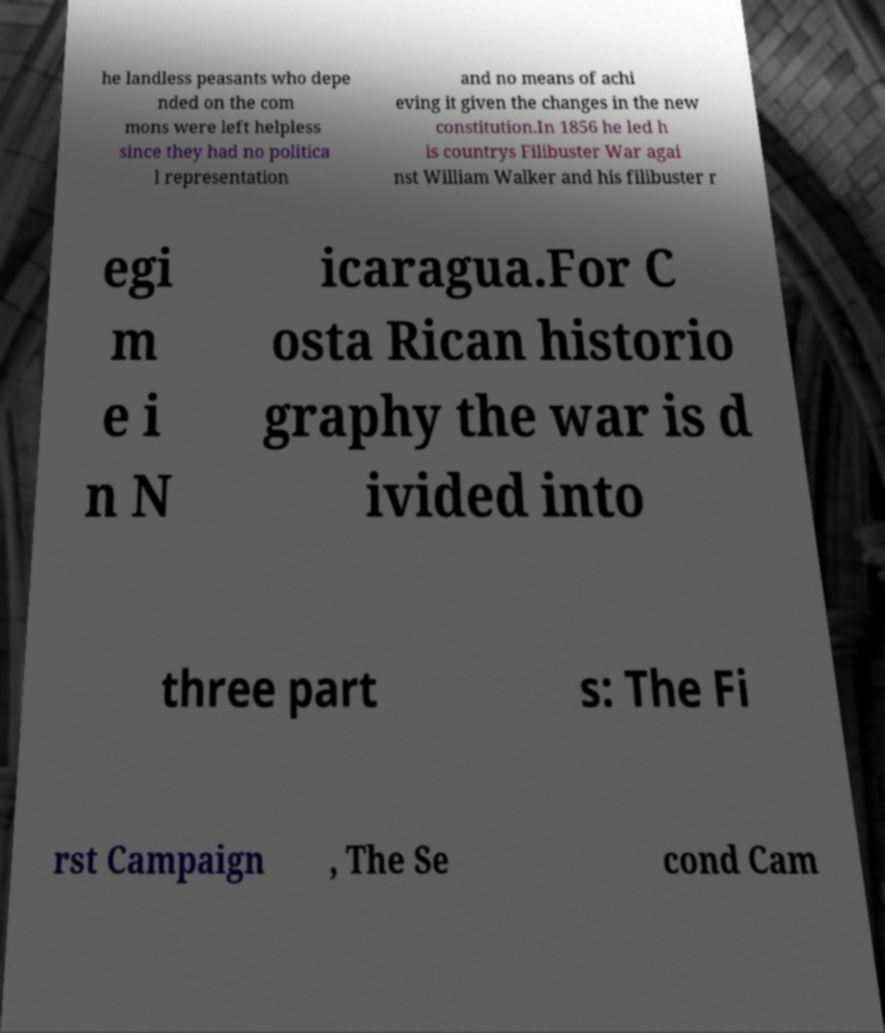What messages or text are displayed in this image? I need them in a readable, typed format. he landless peasants who depe nded on the com mons were left helpless since they had no politica l representation and no means of achi eving it given the changes in the new constitution.In 1856 he led h is countrys Filibuster War agai nst William Walker and his filibuster r egi m e i n N icaragua.For C osta Rican historio graphy the war is d ivided into three part s: The Fi rst Campaign , The Se cond Cam 